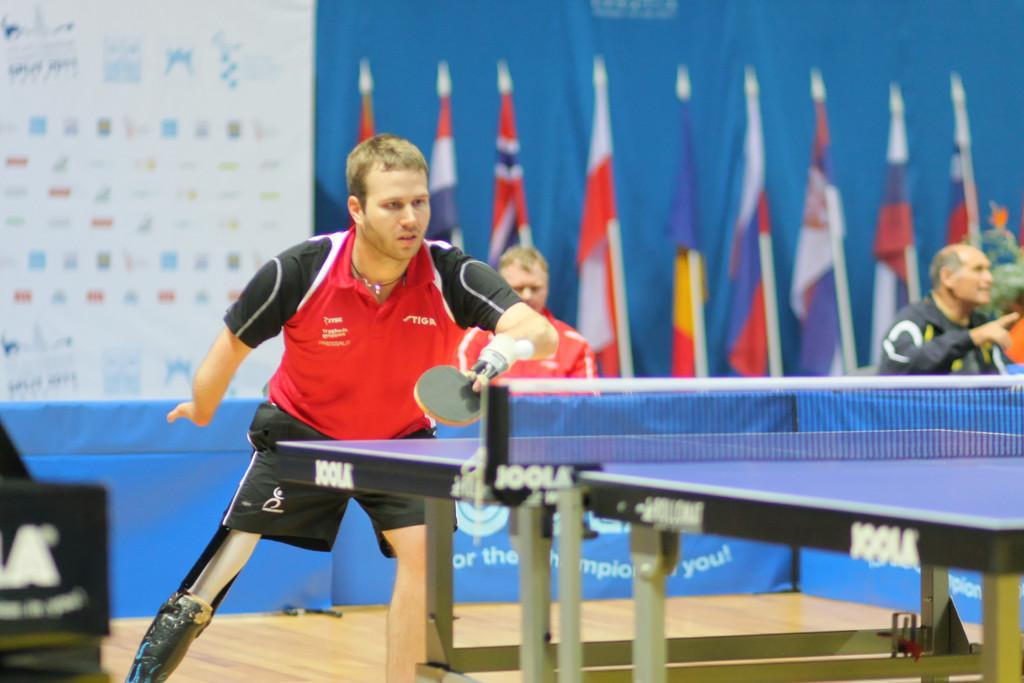<image>
Write a terse but informative summary of the picture. A ping pong table has Joola below the net. 